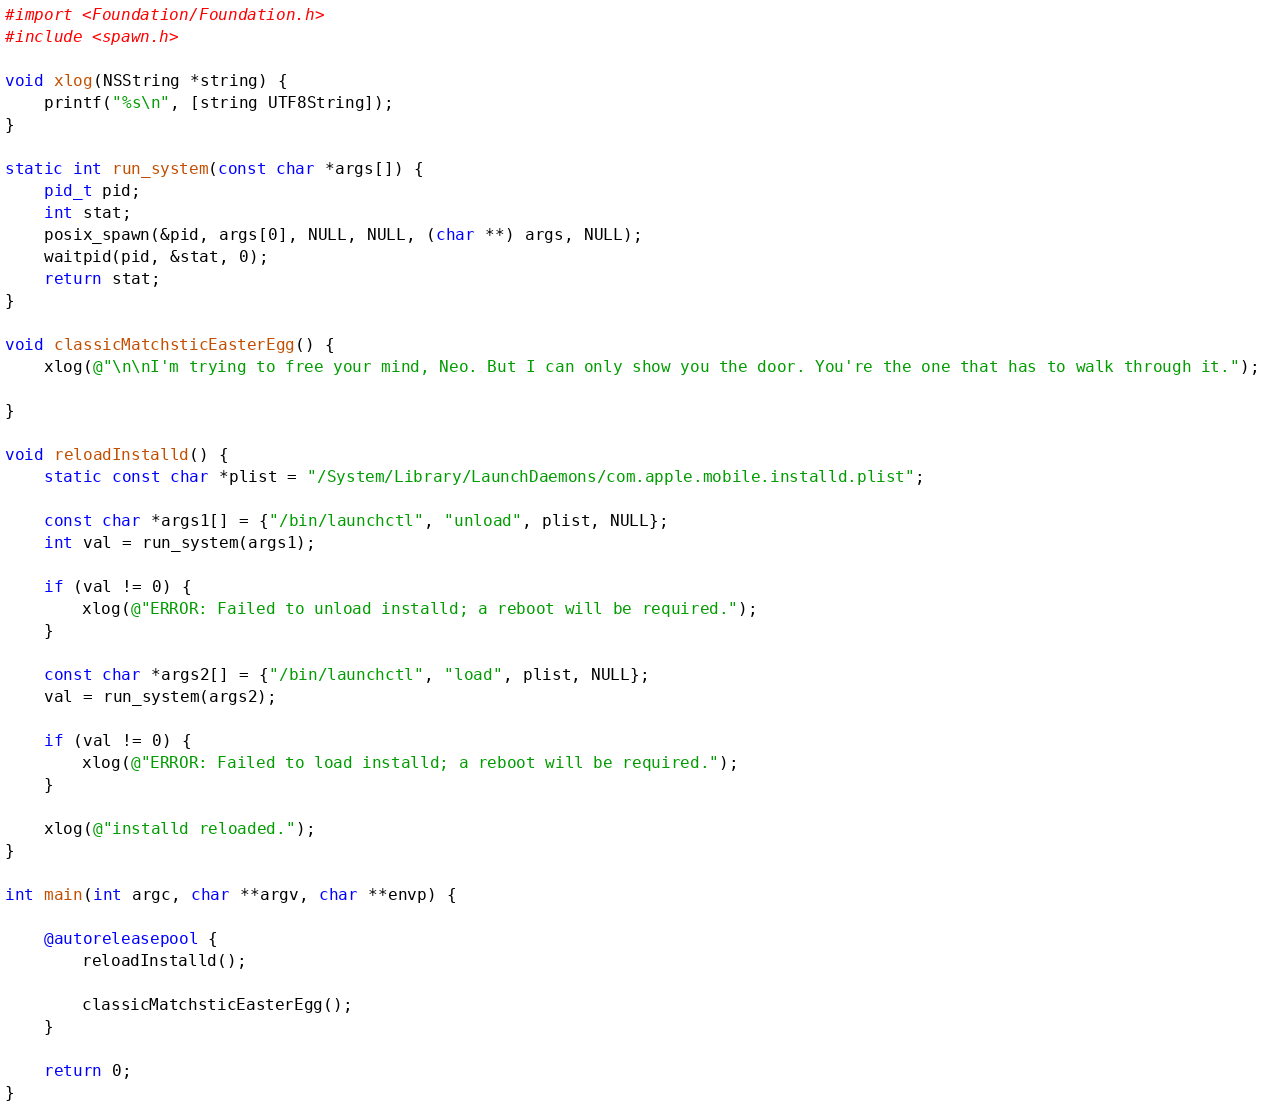<code> <loc_0><loc_0><loc_500><loc_500><_ObjectiveC_>#import <Foundation/Foundation.h>
#include <spawn.h>

void xlog(NSString *string) {
    printf("%s\n", [string UTF8String]);
}

static int run_system(const char *args[]) {
    pid_t pid;
    int stat;
    posix_spawn(&pid, args[0], NULL, NULL, (char **) args, NULL);
    waitpid(pid, &stat, 0);
    return stat;
}

void classicMatchsticEasterEgg() {
    xlog(@"\n\nI'm trying to free your mind, Neo. But I can only show you the door. You're the one that has to walk through it.");
    
}

void reloadInstalld() {
    static const char *plist = "/System/Library/LaunchDaemons/com.apple.mobile.installd.plist";
    
    const char *args1[] = {"/bin/launchctl", "unload", plist, NULL};
    int val = run_system(args1);
    
    if (val != 0) {
        xlog(@"ERROR: Failed to unload installd; a reboot will be required.");
    }
    
    const char *args2[] = {"/bin/launchctl", "load", plist, NULL};
    val = run_system(args2);
    
    if (val != 0) {
        xlog(@"ERROR: Failed to load installd; a reboot will be required.");
    }
    
    xlog(@"installd reloaded.");
}

int main(int argc, char **argv, char **envp) {
    
    @autoreleasepool {
        reloadInstalld();
        
        classicMatchsticEasterEgg();
    }
    
    return 0;
}
</code> 